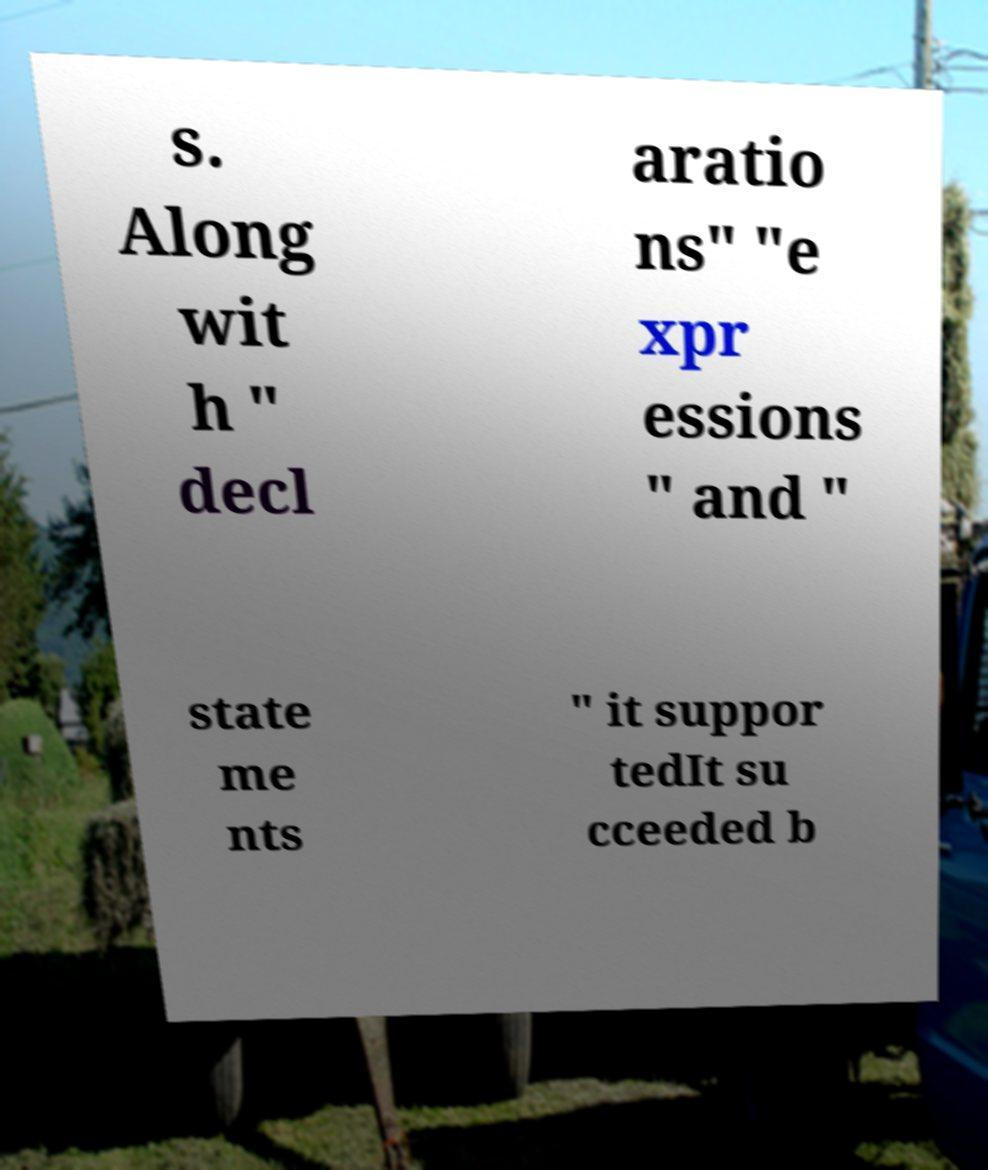Can you read and provide the text displayed in the image?This photo seems to have some interesting text. Can you extract and type it out for me? s. Along wit h " decl aratio ns" "e xpr essions " and " state me nts " it suppor tedIt su cceeded b 